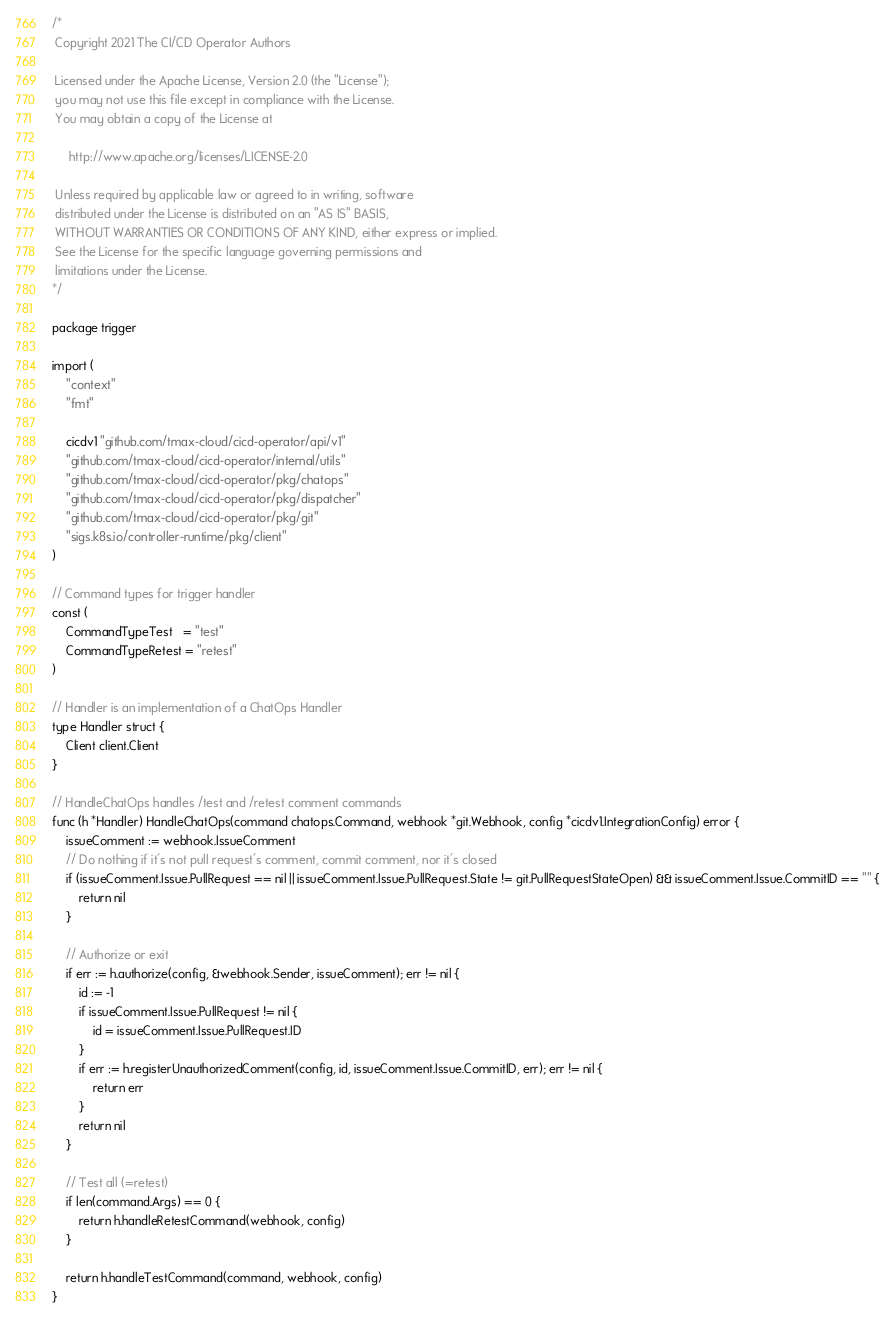Convert code to text. <code><loc_0><loc_0><loc_500><loc_500><_Go_>/*
 Copyright 2021 The CI/CD Operator Authors

 Licensed under the Apache License, Version 2.0 (the "License");
 you may not use this file except in compliance with the License.
 You may obtain a copy of the License at

     http://www.apache.org/licenses/LICENSE-2.0

 Unless required by applicable law or agreed to in writing, software
 distributed under the License is distributed on an "AS IS" BASIS,
 WITHOUT WARRANTIES OR CONDITIONS OF ANY KIND, either express or implied.
 See the License for the specific language governing permissions and
 limitations under the License.
*/

package trigger

import (
	"context"
	"fmt"

	cicdv1 "github.com/tmax-cloud/cicd-operator/api/v1"
	"github.com/tmax-cloud/cicd-operator/internal/utils"
	"github.com/tmax-cloud/cicd-operator/pkg/chatops"
	"github.com/tmax-cloud/cicd-operator/pkg/dispatcher"
	"github.com/tmax-cloud/cicd-operator/pkg/git"
	"sigs.k8s.io/controller-runtime/pkg/client"
)

// Command types for trigger handler
const (
	CommandTypeTest   = "test"
	CommandTypeRetest = "retest"
)

// Handler is an implementation of a ChatOps Handler
type Handler struct {
	Client client.Client
}

// HandleChatOps handles /test and /retest comment commands
func (h *Handler) HandleChatOps(command chatops.Command, webhook *git.Webhook, config *cicdv1.IntegrationConfig) error {
	issueComment := webhook.IssueComment
	// Do nothing if it's not pull request's comment, commit comment, nor it's closed
	if (issueComment.Issue.PullRequest == nil || issueComment.Issue.PullRequest.State != git.PullRequestStateOpen) && issueComment.Issue.CommitID == "" {
		return nil
	}

	// Authorize or exit
	if err := h.authorize(config, &webhook.Sender, issueComment); err != nil {
		id := -1
		if issueComment.Issue.PullRequest != nil {
			id = issueComment.Issue.PullRequest.ID
		}
		if err := h.registerUnauthorizedComment(config, id, issueComment.Issue.CommitID, err); err != nil {
			return err
		}
		return nil
	}

	// Test all (=retest)
	if len(command.Args) == 0 {
		return h.handleRetestCommand(webhook, config)
	}

	return h.handleTestCommand(command, webhook, config)
}
</code> 